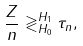Convert formula to latex. <formula><loc_0><loc_0><loc_500><loc_500>\frac { Z } { n } \gtrless _ { H _ { 0 } } ^ { H _ { 1 } } \tau _ { n } ,</formula> 